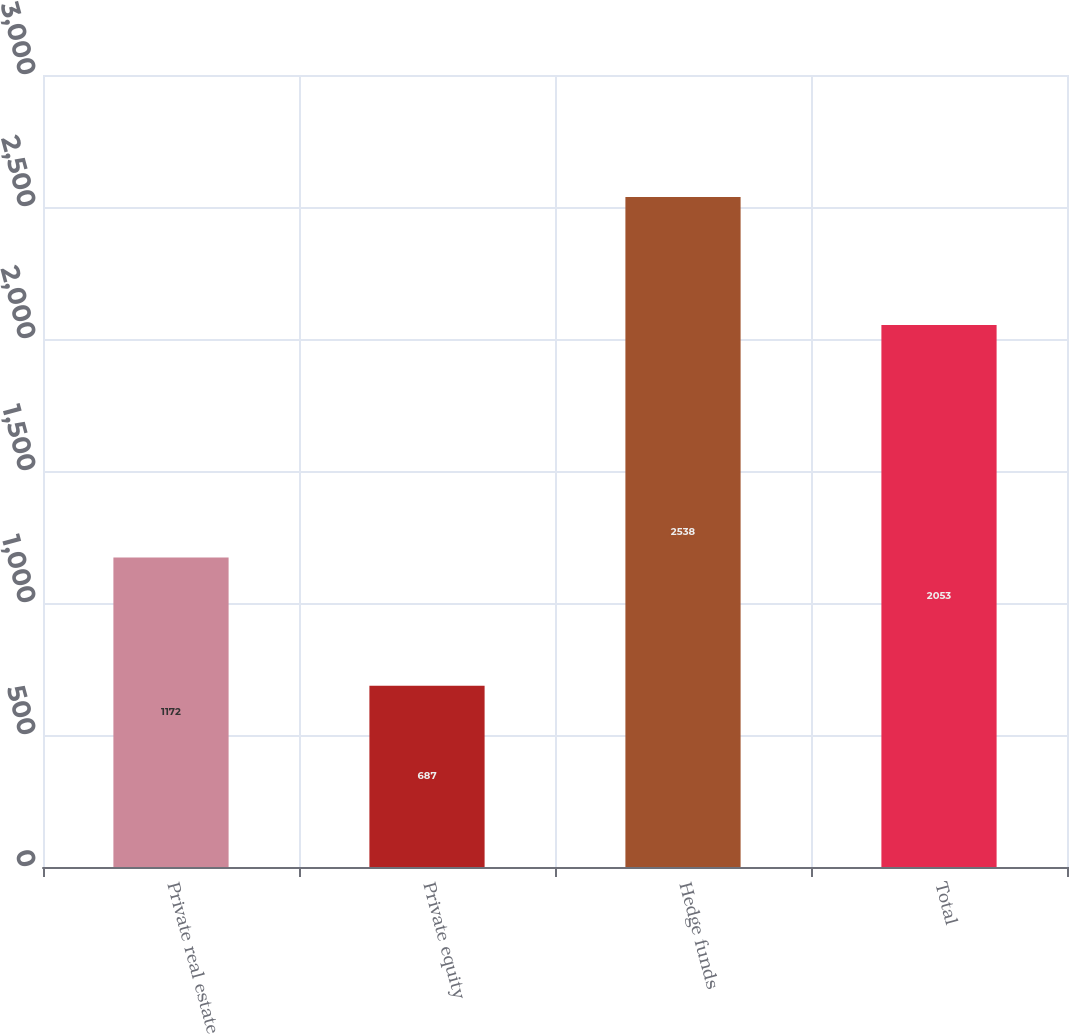Convert chart to OTSL. <chart><loc_0><loc_0><loc_500><loc_500><bar_chart><fcel>Private real estate<fcel>Private equity<fcel>Hedge funds<fcel>Total<nl><fcel>1172<fcel>687<fcel>2538<fcel>2053<nl></chart> 